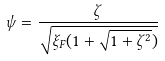<formula> <loc_0><loc_0><loc_500><loc_500>\psi = \frac { \zeta } { \sqrt { \xi _ { F } ( 1 + \sqrt { 1 + \zeta ^ { 2 } } ) } }</formula> 